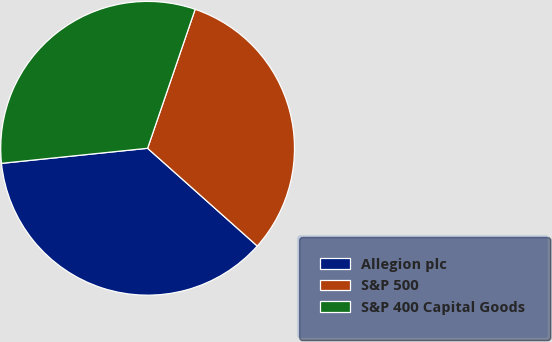<chart> <loc_0><loc_0><loc_500><loc_500><pie_chart><fcel>Allegion plc<fcel>S&P 500<fcel>S&P 400 Capital Goods<nl><fcel>36.78%<fcel>31.34%<fcel>31.88%<nl></chart> 